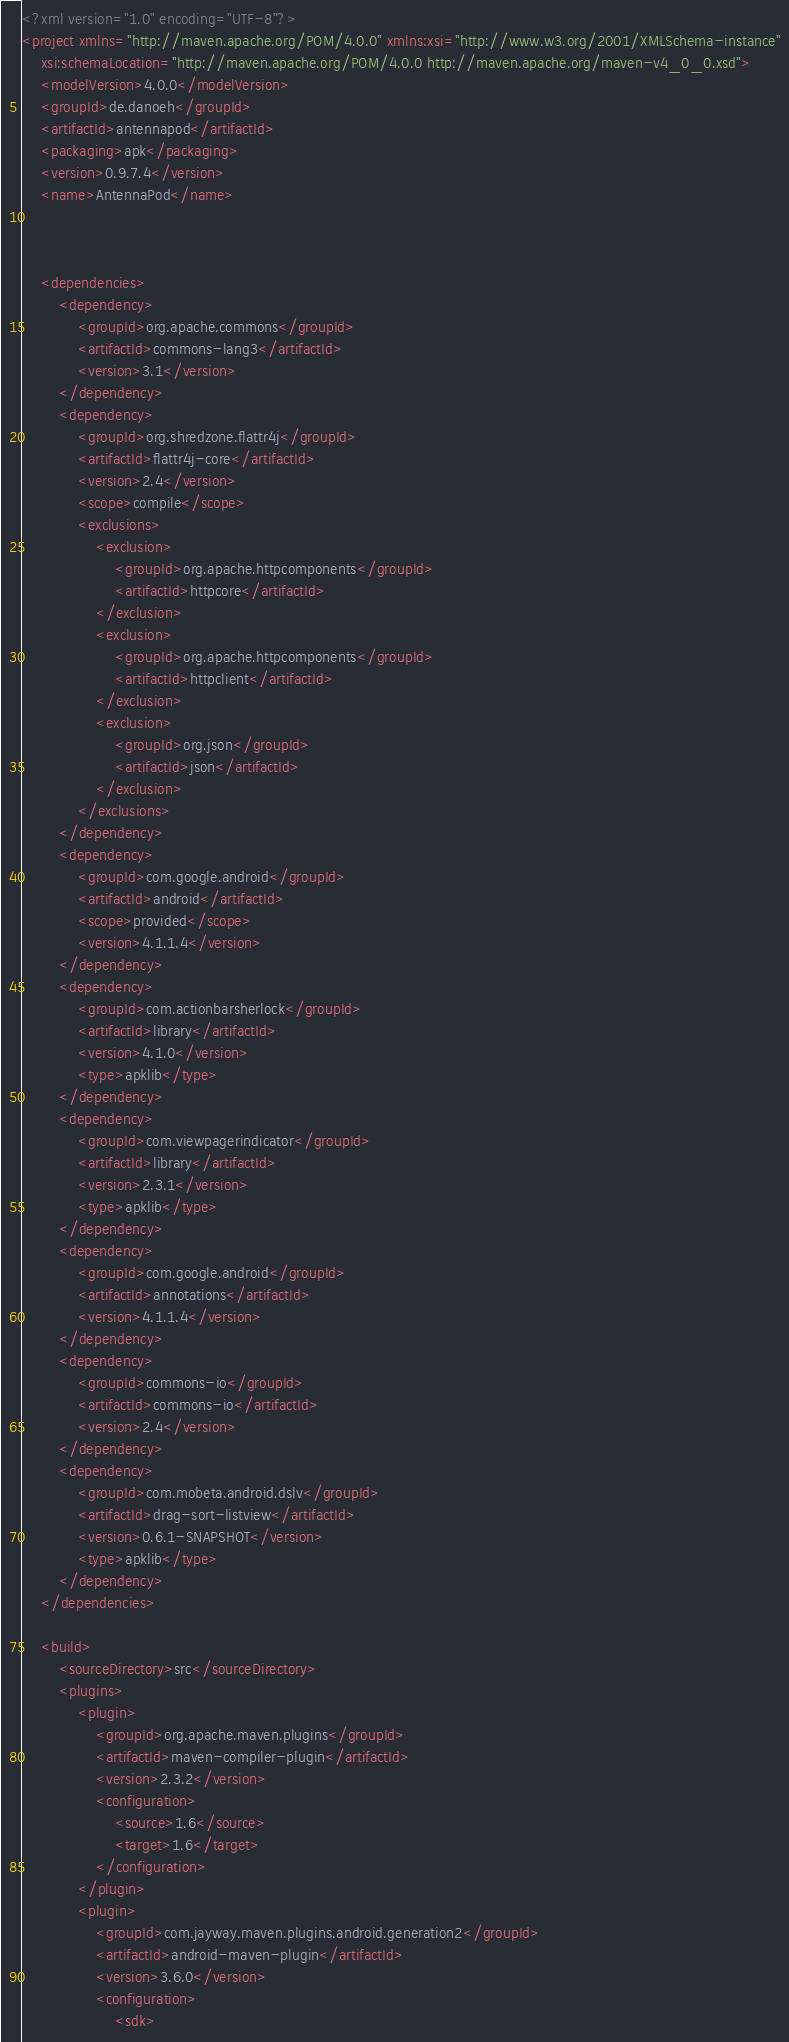Convert code to text. <code><loc_0><loc_0><loc_500><loc_500><_XML_><?xml version="1.0" encoding="UTF-8"?>
<project xmlns="http://maven.apache.org/POM/4.0.0" xmlns:xsi="http://www.w3.org/2001/XMLSchema-instance"
	xsi:schemaLocation="http://maven.apache.org/POM/4.0.0 http://maven.apache.org/maven-v4_0_0.xsd">
	<modelVersion>4.0.0</modelVersion>
	<groupId>de.danoeh</groupId>
	<artifactId>antennapod</artifactId>
	<packaging>apk</packaging>
	<version>0.9.7.4</version>
	<name>AntennaPod</name>



	<dependencies>
		<dependency>
			<groupId>org.apache.commons</groupId>
			<artifactId>commons-lang3</artifactId>
			<version>3.1</version>
		</dependency>
		<dependency>
			<groupId>org.shredzone.flattr4j</groupId>
			<artifactId>flattr4j-core</artifactId>
			<version>2.4</version>
			<scope>compile</scope>
			<exclusions>
				<exclusion>
					<groupId>org.apache.httpcomponents</groupId>
					<artifactId>httpcore</artifactId>
				</exclusion>
				<exclusion>
					<groupId>org.apache.httpcomponents</groupId>
					<artifactId>httpclient</artifactId>
				</exclusion>
				<exclusion>
					<groupId>org.json</groupId>
					<artifactId>json</artifactId>
				</exclusion>
			</exclusions>
		</dependency>
		<dependency>
			<groupId>com.google.android</groupId>
			<artifactId>android</artifactId>
			<scope>provided</scope>
			<version>4.1.1.4</version>
		</dependency>
		<dependency>
			<groupId>com.actionbarsherlock</groupId>
			<artifactId>library</artifactId>
			<version>4.1.0</version>
			<type>apklib</type>
		</dependency>
		<dependency>
			<groupId>com.viewpagerindicator</groupId>
			<artifactId>library</artifactId>
			<version>2.3.1</version>
			<type>apklib</type>
		</dependency>
		<dependency>
			<groupId>com.google.android</groupId>
			<artifactId>annotations</artifactId>
			<version>4.1.1.4</version>
		</dependency>
		<dependency>
			<groupId>commons-io</groupId>
			<artifactId>commons-io</artifactId>
			<version>2.4</version>
		</dependency>
		<dependency>
			<groupId>com.mobeta.android.dslv</groupId>
			<artifactId>drag-sort-listview</artifactId>
			<version>0.6.1-SNAPSHOT</version>
			<type>apklib</type>
		</dependency>
	</dependencies>

	<build>
		<sourceDirectory>src</sourceDirectory>
		<plugins>
			<plugin>
				<groupId>org.apache.maven.plugins</groupId>
				<artifactId>maven-compiler-plugin</artifactId>
				<version>2.3.2</version>
				<configuration>
					<source>1.6</source>
					<target>1.6</target>
				</configuration>
			</plugin>
			<plugin>
				<groupId>com.jayway.maven.plugins.android.generation2</groupId>
				<artifactId>android-maven-plugin</artifactId>
				<version>3.6.0</version>
				<configuration>
					<sdk></code> 